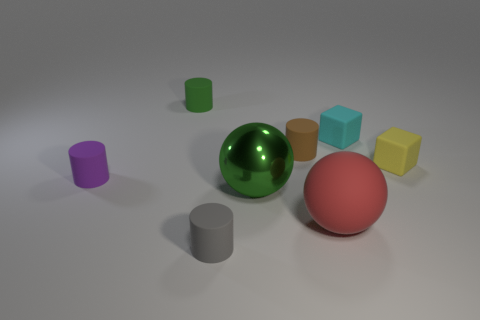Subtract 1 cylinders. How many cylinders are left? 3 Subtract all brown cylinders. How many cylinders are left? 3 Subtract all yellow cylinders. Subtract all red spheres. How many cylinders are left? 4 Add 1 tiny gray things. How many objects exist? 9 Subtract all spheres. How many objects are left? 6 Add 8 big red rubber spheres. How many big red rubber spheres are left? 9 Add 7 large green cylinders. How many large green cylinders exist? 7 Subtract 1 brown cylinders. How many objects are left? 7 Subtract all gray cylinders. Subtract all tiny purple matte cylinders. How many objects are left? 6 